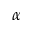Convert formula to latex. <formula><loc_0><loc_0><loc_500><loc_500>\alpha</formula> 